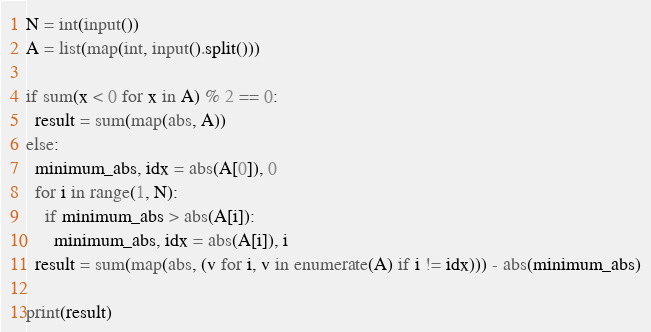<code> <loc_0><loc_0><loc_500><loc_500><_Python_>N = int(input())
A = list(map(int, input().split()))

if sum(x < 0 for x in A) % 2 == 0:
  result = sum(map(abs, A))
else:
  minimum_abs, idx = abs(A[0]), 0
  for i in range(1, N):
    if minimum_abs > abs(A[i]):
      minimum_abs, idx = abs(A[i]), i
  result = sum(map(abs, (v for i, v in enumerate(A) if i != idx))) - abs(minimum_abs)

print(result)
</code> 